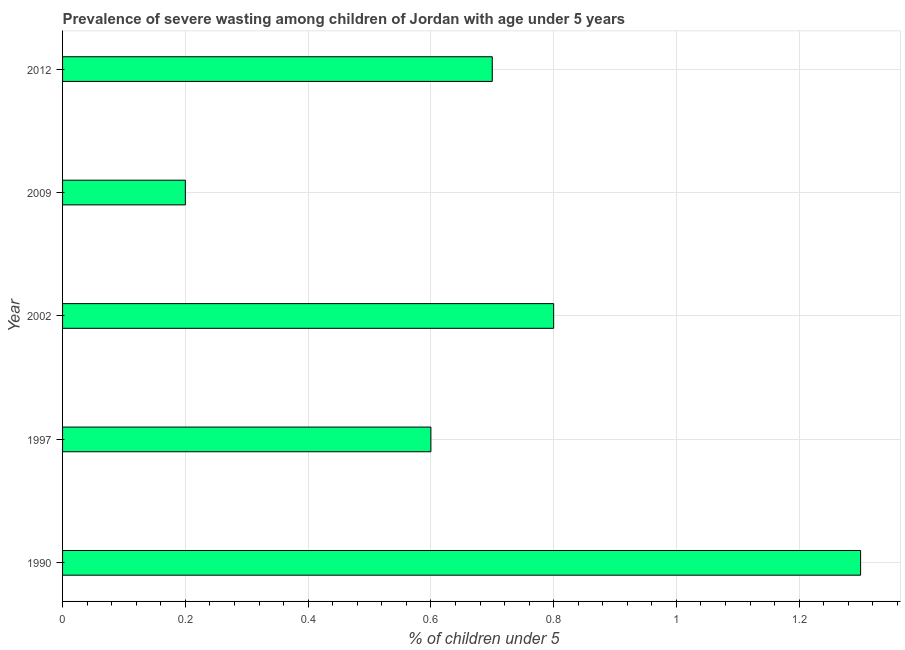Does the graph contain any zero values?
Your answer should be very brief. No. Does the graph contain grids?
Ensure brevity in your answer.  Yes. What is the title of the graph?
Make the answer very short. Prevalence of severe wasting among children of Jordan with age under 5 years. What is the label or title of the X-axis?
Your answer should be very brief.  % of children under 5. What is the prevalence of severe wasting in 1997?
Keep it short and to the point. 0.6. Across all years, what is the maximum prevalence of severe wasting?
Keep it short and to the point. 1.3. Across all years, what is the minimum prevalence of severe wasting?
Your answer should be compact. 0.2. In which year was the prevalence of severe wasting minimum?
Make the answer very short. 2009. What is the sum of the prevalence of severe wasting?
Ensure brevity in your answer.  3.6. What is the difference between the prevalence of severe wasting in 1997 and 2002?
Ensure brevity in your answer.  -0.2. What is the average prevalence of severe wasting per year?
Keep it short and to the point. 0.72. What is the median prevalence of severe wasting?
Your response must be concise. 0.7. Do a majority of the years between 2009 and 2012 (inclusive) have prevalence of severe wasting greater than 0.16 %?
Offer a terse response. Yes. What is the ratio of the prevalence of severe wasting in 2002 to that in 2012?
Offer a terse response. 1.14. Is the sum of the prevalence of severe wasting in 1997 and 2002 greater than the maximum prevalence of severe wasting across all years?
Ensure brevity in your answer.  Yes. In how many years, is the prevalence of severe wasting greater than the average prevalence of severe wasting taken over all years?
Keep it short and to the point. 2. How many bars are there?
Keep it short and to the point. 5. How many years are there in the graph?
Provide a succinct answer. 5. What is the  % of children under 5 in 1990?
Give a very brief answer. 1.3. What is the  % of children under 5 in 1997?
Your response must be concise. 0.6. What is the  % of children under 5 of 2002?
Offer a very short reply. 0.8. What is the  % of children under 5 of 2009?
Your response must be concise. 0.2. What is the  % of children under 5 of 2012?
Provide a succinct answer. 0.7. What is the difference between the  % of children under 5 in 1990 and 2009?
Offer a terse response. 1.1. What is the difference between the  % of children under 5 in 1990 and 2012?
Your response must be concise. 0.6. What is the difference between the  % of children under 5 in 1997 and 2002?
Ensure brevity in your answer.  -0.2. What is the difference between the  % of children under 5 in 1997 and 2009?
Your answer should be compact. 0.4. What is the difference between the  % of children under 5 in 1997 and 2012?
Your answer should be very brief. -0.1. What is the difference between the  % of children under 5 in 2002 and 2009?
Keep it short and to the point. 0.6. What is the difference between the  % of children under 5 in 2002 and 2012?
Give a very brief answer. 0.1. What is the difference between the  % of children under 5 in 2009 and 2012?
Your response must be concise. -0.5. What is the ratio of the  % of children under 5 in 1990 to that in 1997?
Your response must be concise. 2.17. What is the ratio of the  % of children under 5 in 1990 to that in 2002?
Offer a terse response. 1.62. What is the ratio of the  % of children under 5 in 1990 to that in 2009?
Provide a short and direct response. 6.5. What is the ratio of the  % of children under 5 in 1990 to that in 2012?
Offer a terse response. 1.86. What is the ratio of the  % of children under 5 in 1997 to that in 2002?
Provide a short and direct response. 0.75. What is the ratio of the  % of children under 5 in 1997 to that in 2012?
Provide a short and direct response. 0.86. What is the ratio of the  % of children under 5 in 2002 to that in 2012?
Offer a very short reply. 1.14. What is the ratio of the  % of children under 5 in 2009 to that in 2012?
Give a very brief answer. 0.29. 